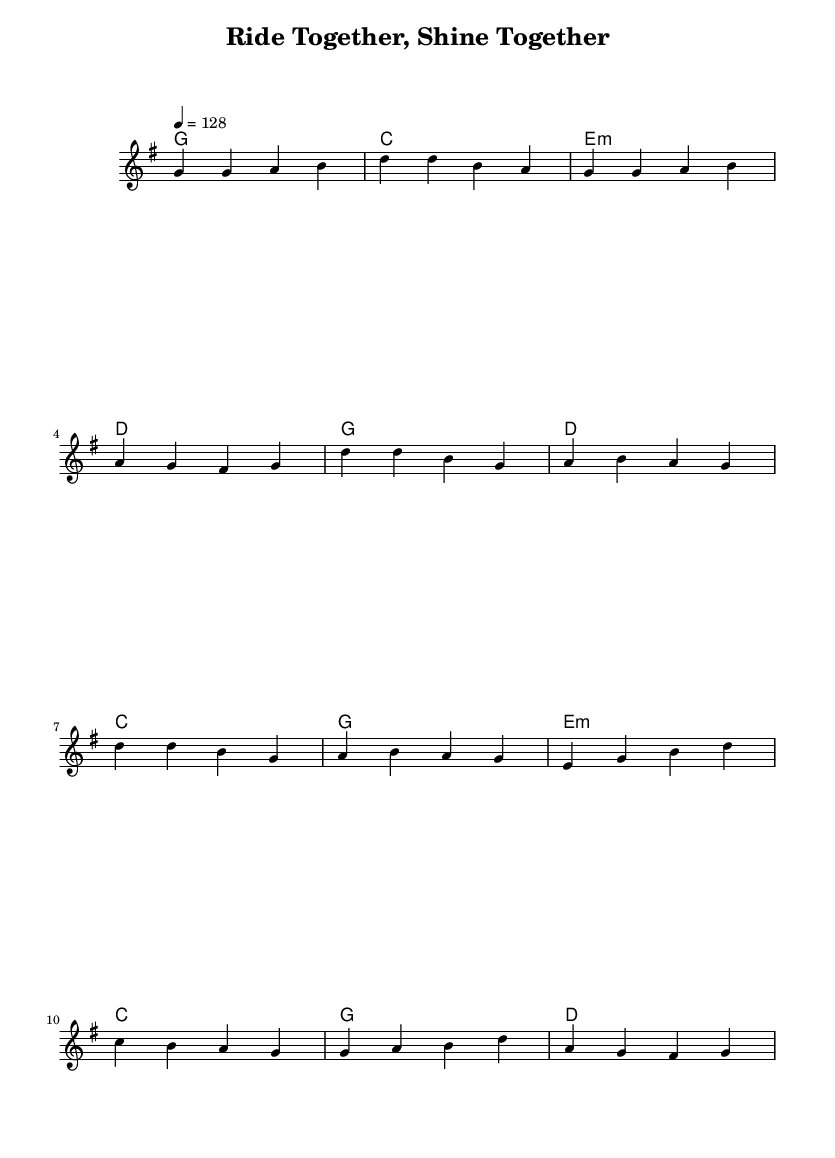What is the key signature of this music? The key signature is G major, which has one sharp (F#). This can be identified in the global section where it is stated as "\key g \major".
Answer: G major What is the time signature of the music? The time signature is 4/4, which means there are four beats in each measure. This is indicated in the global section with "\time 4/4".
Answer: 4/4 What is the tempo marking of this piece? The tempo marking is 128 beats per minute, indicated in the global section by "\tempo 4 = 128".
Answer: 128 What mood is conveyed in the lyrics of this song? The lyrics convey an upbeat and positive mood, emphasizing friendship and togetherness. This is evident in the themes of companionship in the verse and chorus lyrics.
Answer: Upbeat Which chord is used in the chorus? The chords used in the chorus include G, D, and C. These chords are listed in the harmonies section that align with the chorus melody.
Answer: G, D, C What does the bridge's message emphasize about friendship? The bridge emphasizes the value of every moment and smile shared in friendship. This reasoning comes from analyzing the lyrics that highlight how experiences together make the friendship worthwhile.
Answer: Worthwhile 